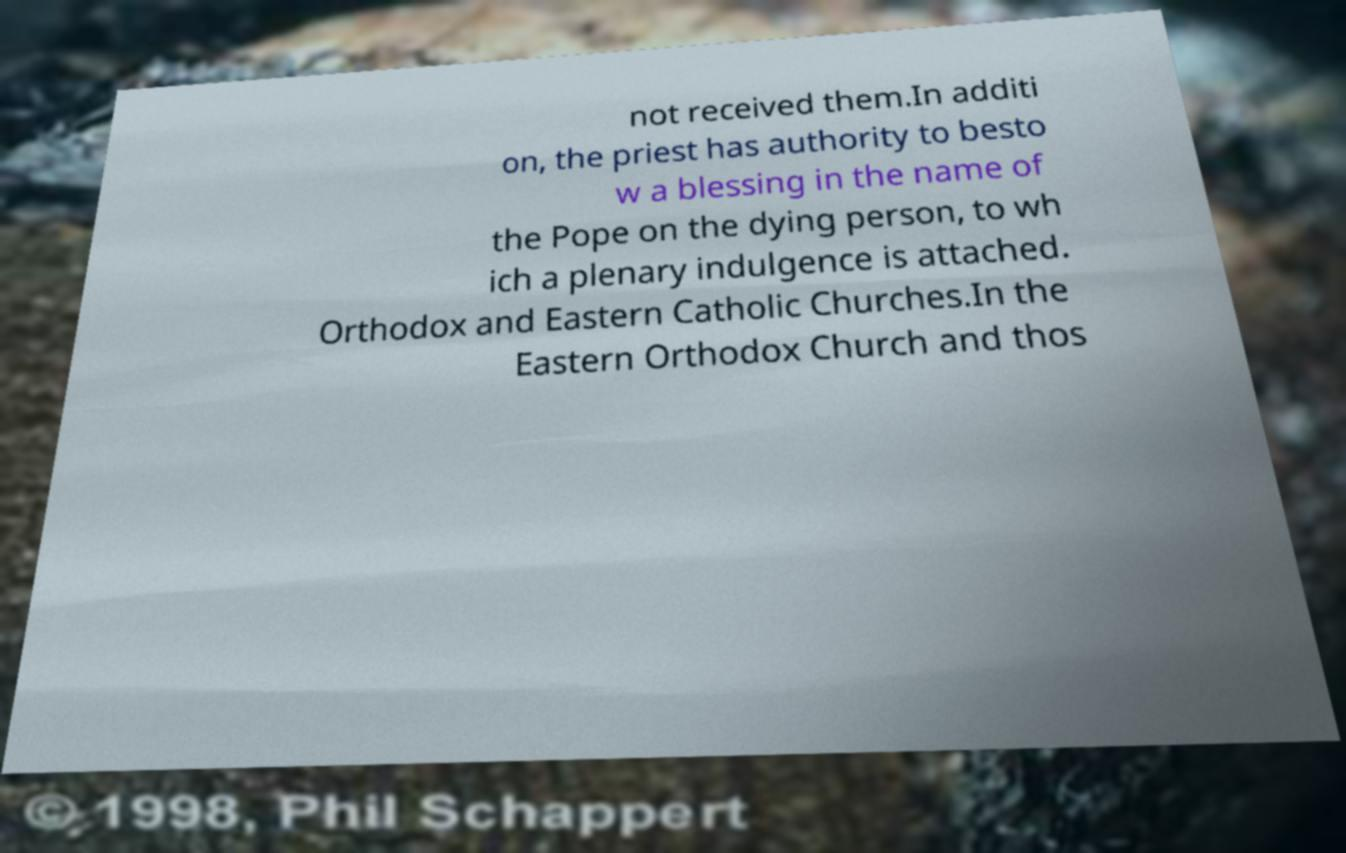Can you accurately transcribe the text from the provided image for me? not received them.In additi on, the priest has authority to besto w a blessing in the name of the Pope on the dying person, to wh ich a plenary indulgence is attached. Orthodox and Eastern Catholic Churches.In the Eastern Orthodox Church and thos 